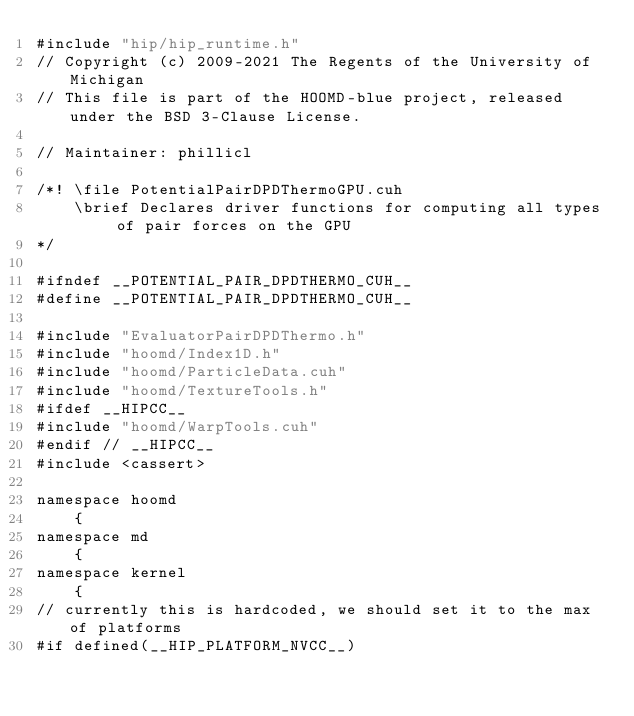<code> <loc_0><loc_0><loc_500><loc_500><_Cuda_>#include "hip/hip_runtime.h"
// Copyright (c) 2009-2021 The Regents of the University of Michigan
// This file is part of the HOOMD-blue project, released under the BSD 3-Clause License.

// Maintainer: phillicl

/*! \file PotentialPairDPDThermoGPU.cuh
    \brief Declares driver functions for computing all types of pair forces on the GPU
*/

#ifndef __POTENTIAL_PAIR_DPDTHERMO_CUH__
#define __POTENTIAL_PAIR_DPDTHERMO_CUH__

#include "EvaluatorPairDPDThermo.h"
#include "hoomd/Index1D.h"
#include "hoomd/ParticleData.cuh"
#include "hoomd/TextureTools.h"
#ifdef __HIPCC__
#include "hoomd/WarpTools.cuh"
#endif // __HIPCC__
#include <cassert>

namespace hoomd
    {
namespace md
    {
namespace kernel
    {
// currently this is hardcoded, we should set it to the max of platforms
#if defined(__HIP_PLATFORM_NVCC__)</code> 